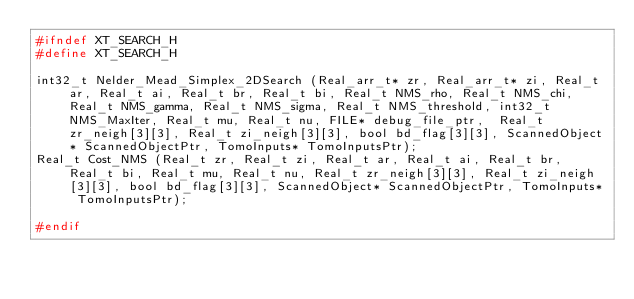Convert code to text. <code><loc_0><loc_0><loc_500><loc_500><_C_>#ifndef XT_SEARCH_H
#define XT_SEARCH_H

int32_t Nelder_Mead_Simplex_2DSearch (Real_arr_t* zr, Real_arr_t* zi, Real_t ar, Real_t ai, Real_t br, Real_t bi, Real_t NMS_rho, Real_t NMS_chi, Real_t NMS_gamma, Real_t NMS_sigma, Real_t NMS_threshold, int32_t NMS_MaxIter, Real_t mu, Real_t nu, FILE* debug_file_ptr,  Real_t zr_neigh[3][3], Real_t zi_neigh[3][3], bool bd_flag[3][3], ScannedObject* ScannedObjectPtr, TomoInputs* TomoInputsPtr);
Real_t Cost_NMS (Real_t zr, Real_t zi, Real_t ar, Real_t ai, Real_t br, Real_t bi, Real_t mu, Real_t nu, Real_t zr_neigh[3][3], Real_t zi_neigh[3][3], bool bd_flag[3][3], ScannedObject* ScannedObjectPtr, TomoInputs* TomoInputsPtr);

#endif

</code> 